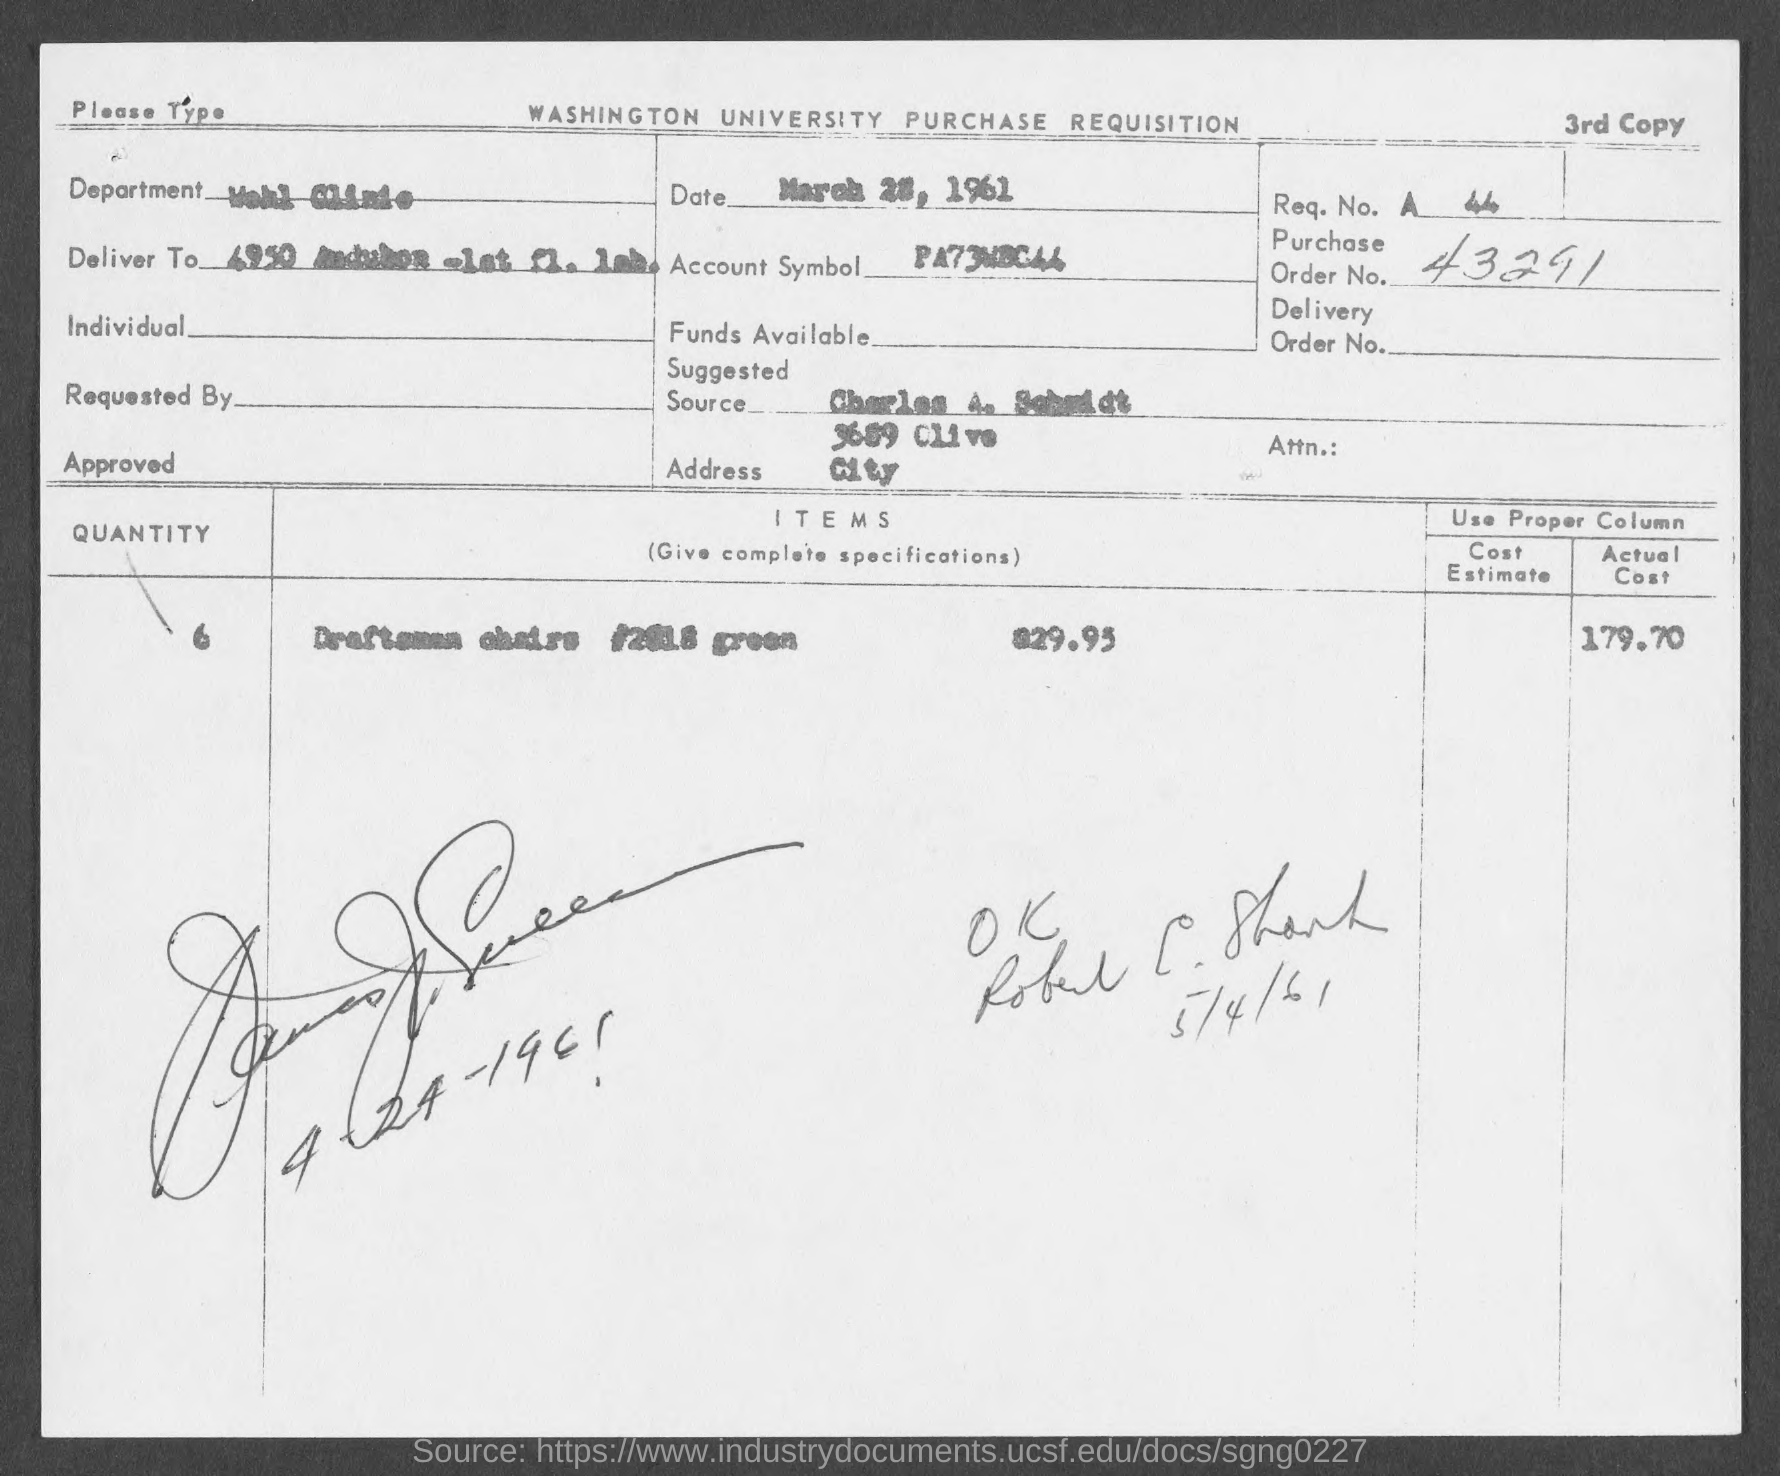What is the purchase order no.?
Your answer should be very brief. 43291. 